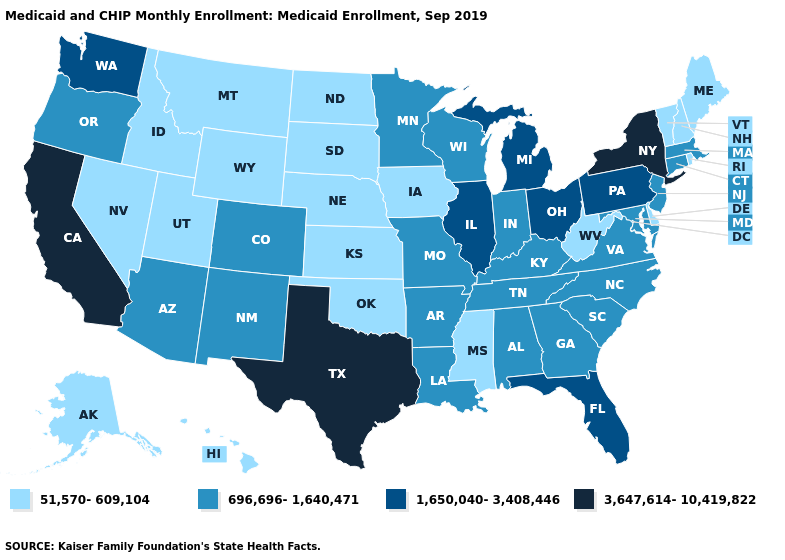Which states have the lowest value in the USA?
Write a very short answer. Alaska, Delaware, Hawaii, Idaho, Iowa, Kansas, Maine, Mississippi, Montana, Nebraska, Nevada, New Hampshire, North Dakota, Oklahoma, Rhode Island, South Dakota, Utah, Vermont, West Virginia, Wyoming. Does the first symbol in the legend represent the smallest category?
Quick response, please. Yes. What is the value of Arizona?
Be succinct. 696,696-1,640,471. What is the value of West Virginia?
Give a very brief answer. 51,570-609,104. What is the value of Tennessee?
Write a very short answer. 696,696-1,640,471. Does the map have missing data?
Quick response, please. No. Does California have a lower value than South Dakota?
Short answer required. No. Among the states that border Florida , which have the lowest value?
Write a very short answer. Alabama, Georgia. What is the value of Maine?
Write a very short answer. 51,570-609,104. What is the value of Maine?
Concise answer only. 51,570-609,104. What is the value of Alaska?
Give a very brief answer. 51,570-609,104. Name the states that have a value in the range 51,570-609,104?
Concise answer only. Alaska, Delaware, Hawaii, Idaho, Iowa, Kansas, Maine, Mississippi, Montana, Nebraska, Nevada, New Hampshire, North Dakota, Oklahoma, Rhode Island, South Dakota, Utah, Vermont, West Virginia, Wyoming. Which states have the lowest value in the West?
Write a very short answer. Alaska, Hawaii, Idaho, Montana, Nevada, Utah, Wyoming. Among the states that border Louisiana , which have the lowest value?
Give a very brief answer. Mississippi. 